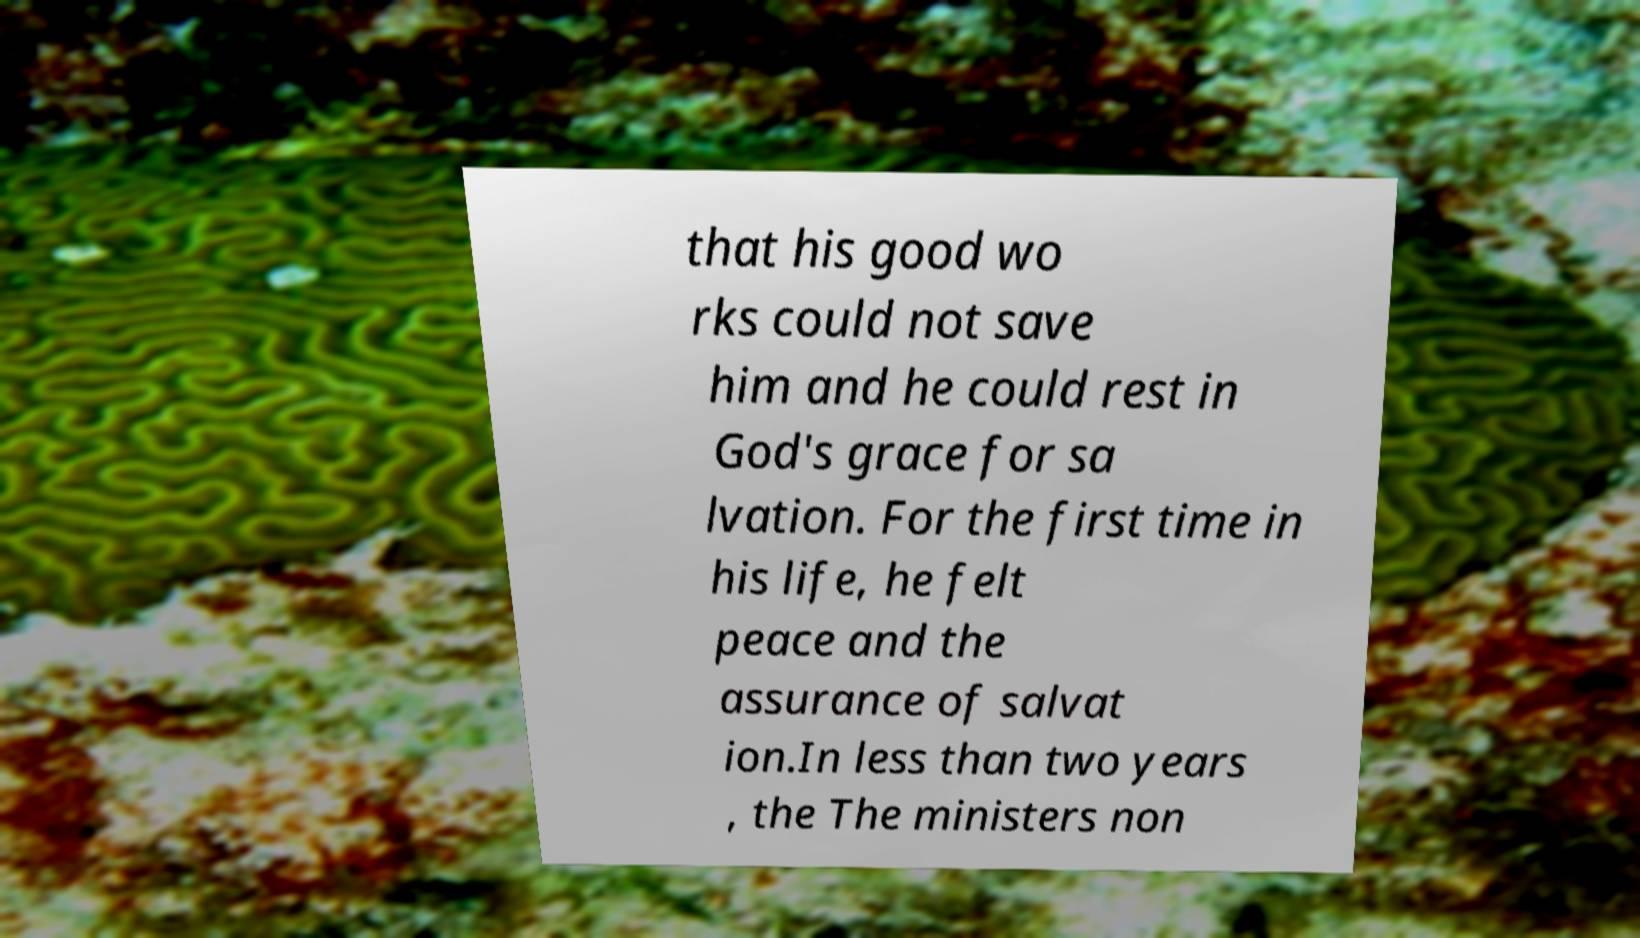Could you extract and type out the text from this image? that his good wo rks could not save him and he could rest in God's grace for sa lvation. For the first time in his life, he felt peace and the assurance of salvat ion.In less than two years , the The ministers non 